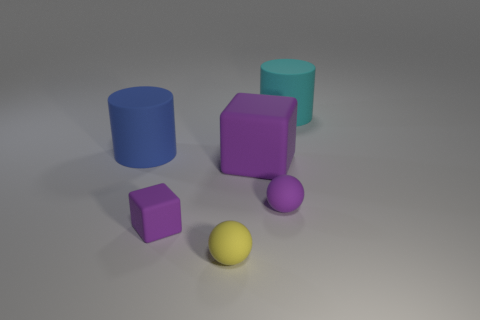There is a yellow rubber object that is the same size as the purple rubber ball; what is its shape?
Offer a terse response. Sphere. Is the color of the tiny cube the same as the big block?
Provide a short and direct response. Yes. Are there any rubber objects that are in front of the cylinder to the right of the blue cylinder?
Offer a terse response. Yes. Are there any blue cylinders that have the same size as the cyan matte cylinder?
Ensure brevity in your answer.  Yes. Is the color of the matte cube that is in front of the small purple sphere the same as the large rubber cube?
Provide a succinct answer. Yes. How big is the blue thing?
Your answer should be very brief. Large. What size is the block that is on the left side of the purple rubber block behind the purple matte ball?
Give a very brief answer. Small. What number of big cubes have the same color as the tiny block?
Your answer should be very brief. 1. What number of small gray metallic cylinders are there?
Your response must be concise. 0. What number of big green blocks are made of the same material as the yellow thing?
Offer a terse response. 0. 